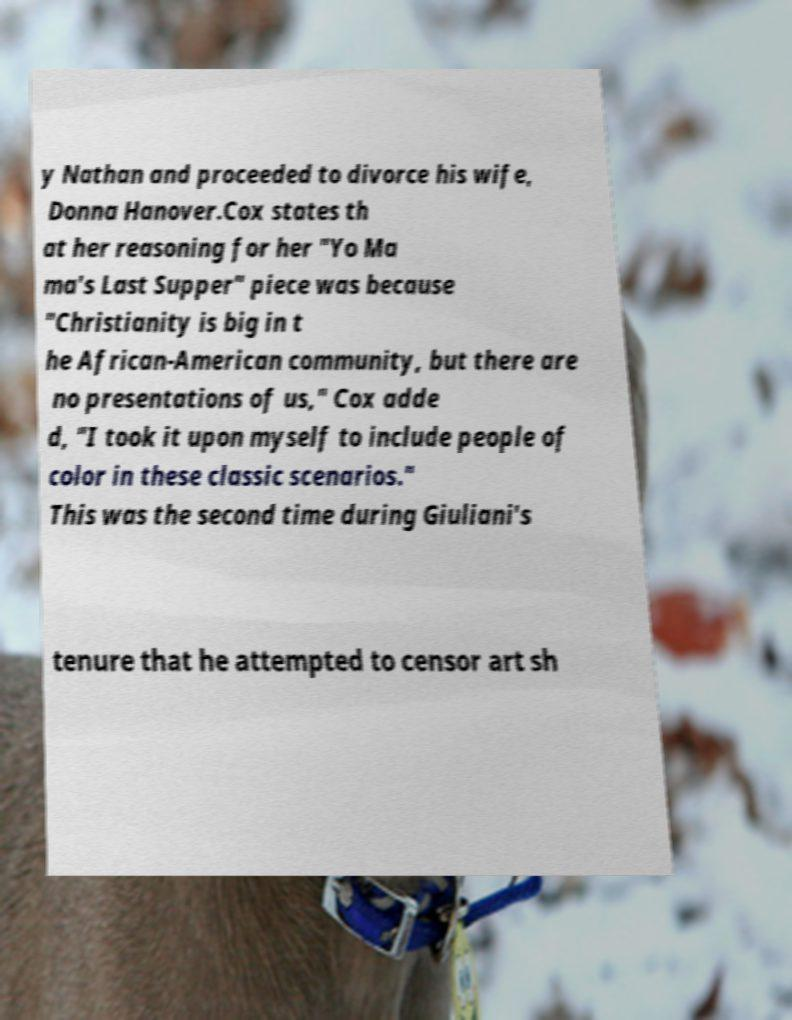There's text embedded in this image that I need extracted. Can you transcribe it verbatim? y Nathan and proceeded to divorce his wife, Donna Hanover.Cox states th at her reasoning for her "Yo Ma ma's Last Supper" piece was because "Christianity is big in t he African-American community, but there are no presentations of us," Cox adde d, "I took it upon myself to include people of color in these classic scenarios." This was the second time during Giuliani's tenure that he attempted to censor art sh 